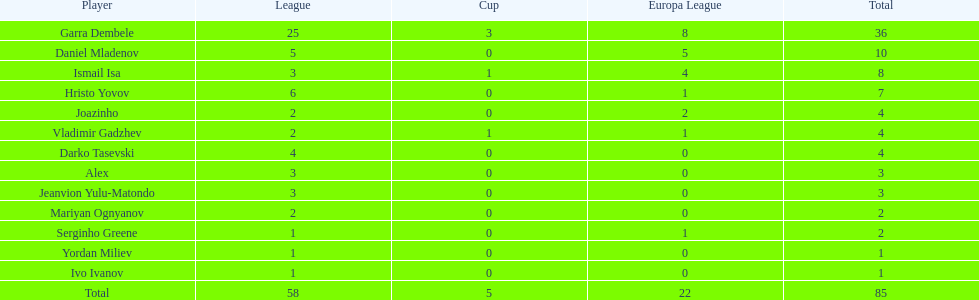Who had the most goal scores? Garra Dembele. 